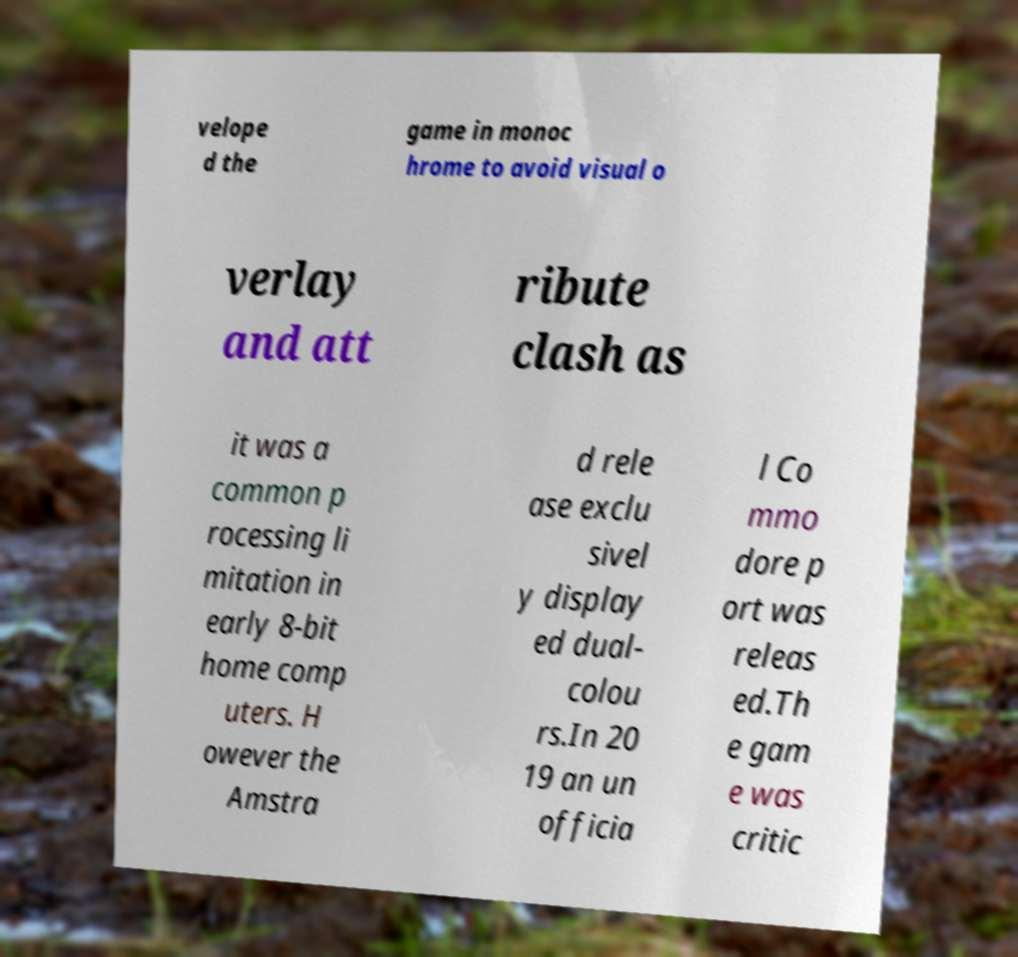What messages or text are displayed in this image? I need them in a readable, typed format. velope d the game in monoc hrome to avoid visual o verlay and att ribute clash as it was a common p rocessing li mitation in early 8-bit home comp uters. H owever the Amstra d rele ase exclu sivel y display ed dual- colou rs.In 20 19 an un officia l Co mmo dore p ort was releas ed.Th e gam e was critic 